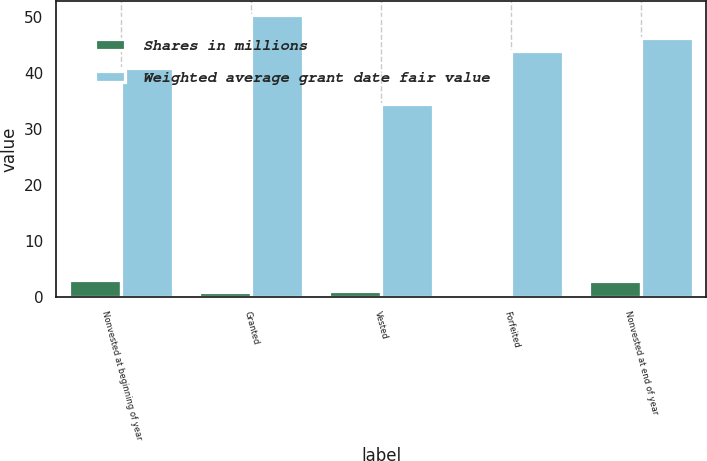Convert chart to OTSL. <chart><loc_0><loc_0><loc_500><loc_500><stacked_bar_chart><ecel><fcel>Nonvested at beginning of year<fcel>Granted<fcel>Vested<fcel>Forfeited<fcel>Nonvested at end of year<nl><fcel>Shares in millions<fcel>3<fcel>0.9<fcel>1<fcel>0.1<fcel>2.8<nl><fcel>Weighted average grant date fair value<fcel>40.88<fcel>50.34<fcel>34.56<fcel>43.87<fcel>46.33<nl></chart> 